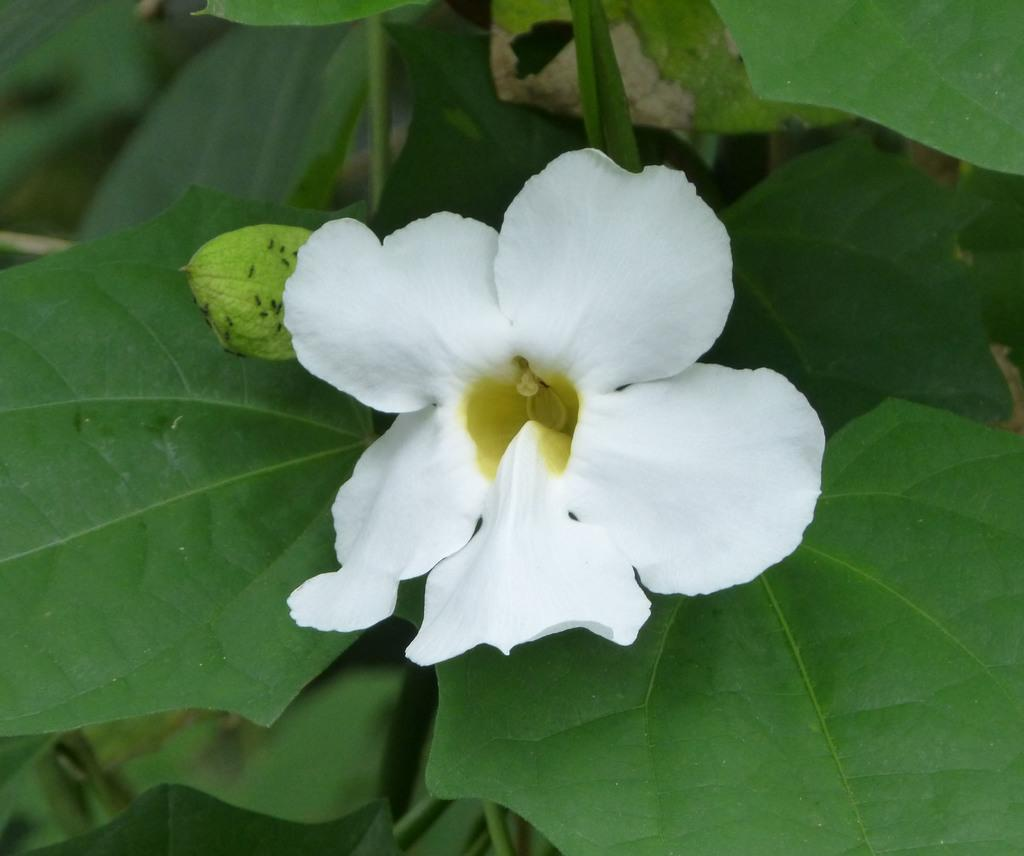What type of living organism can be seen in the image? There is a plant in the image. What color is the flower on the plant? The plant has a white flower. What color are the leaves of the plant? The leaves of the plant are green. What type of fruit can be seen hanging from the plant in the image? There is no fruit visible on the plant in the image. 